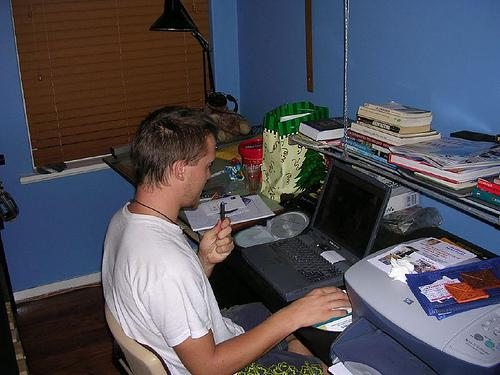Question: who is sitting down?
Choices:
A. The boy.
B. The woman.
C. The man.
D. The girl.
Answer with the letter. Answer: C Question: where is the man?
Choices:
A. In the home.
B. In the chair.
C. In the car.
D. In the bar.
Answer with the letter. Answer: B Question: how many men are there?
Choices:
A. Two.
B. Three.
C. One.
D. Four.
Answer with the letter. Answer: C Question: what is in front of the man?
Choices:
A. The phone.
B. The computer.
C. The bowl.
D. The food.
Answer with the letter. Answer: B Question: what is the laptop on?
Choices:
A. The car.
B. The desk.
C. The table.
D. The shelf.
Answer with the letter. Answer: C Question: where was the picture taken?
Choices:
A. School.
B. Concert.
C. Office.
D. Shopping mall.
Answer with the letter. Answer: C 